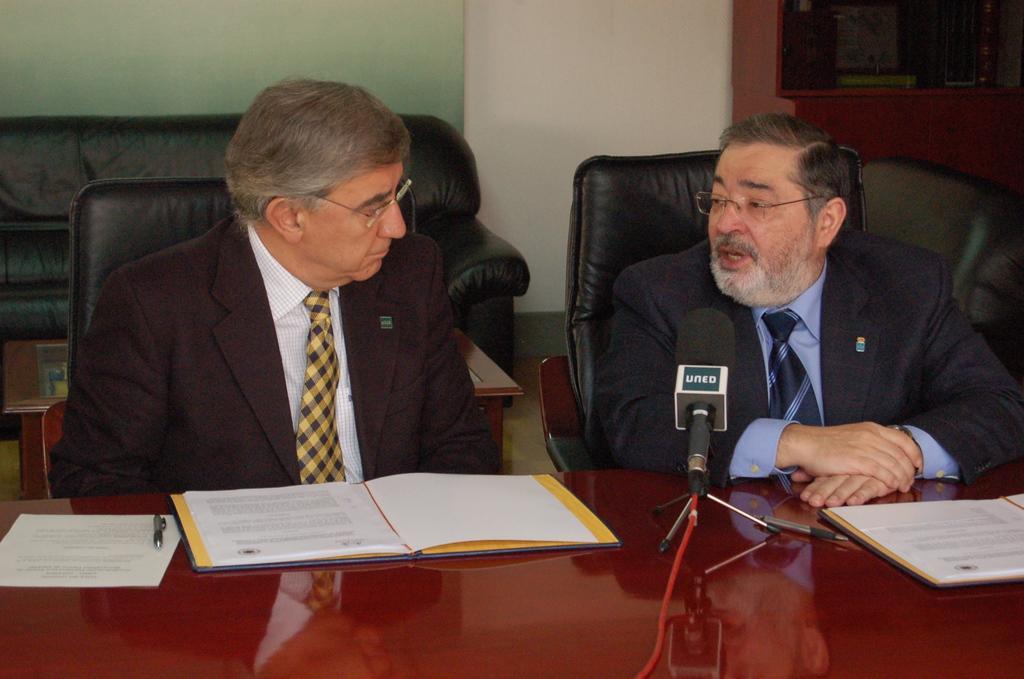Please provide a concise description of this image. In the image we can see two men sitting, wearing clothes, spectacles and they are talking to each other. Here we can see the couch and table. On the table we can see microphone, book, paper and a pen. Here we can see the wall and floor. 